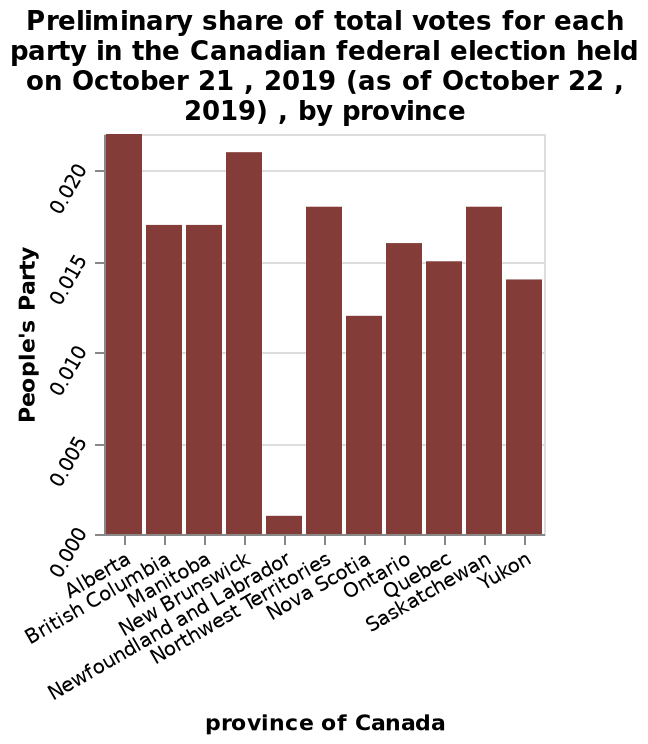<image>
Among all the provinces, which one had the highest no treatment rate?  Newfoundland and Labrador. How many provinces have a minimum number of votes below 0.005?  One province, Newfoundland and Labrador. Describe the following image in detail Here a bar chart is called Preliminary share of total votes for each party in the Canadian federal election held on October 21 , 2019 (as of October 22 , 2019) , by province. A categorical scale starting with Alberta and ending with Yukon can be seen on the x-axis, labeled province of Canada. People's Party is shown with a linear scale from 0.000 to 0.020 along the y-axis. What is represented on the x-axis of the bar chart?  The x-axis of the bar chart represents the provinces of Canada. 